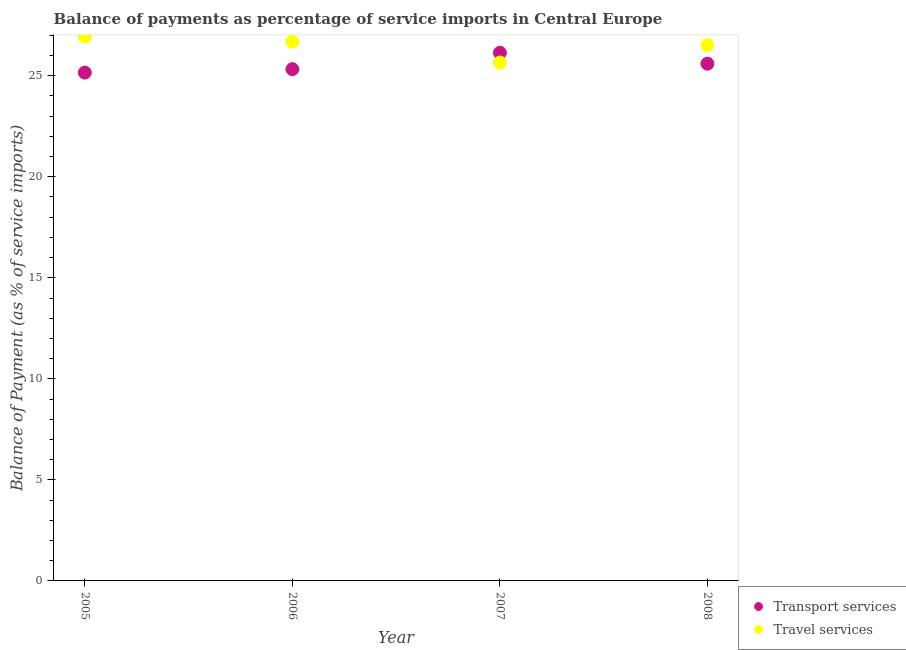What is the balance of payments of travel services in 2007?
Offer a very short reply. 25.65. Across all years, what is the maximum balance of payments of travel services?
Make the answer very short. 26.93. Across all years, what is the minimum balance of payments of travel services?
Ensure brevity in your answer.  25.65. What is the total balance of payments of transport services in the graph?
Keep it short and to the point. 102.22. What is the difference between the balance of payments of travel services in 2005 and that in 2007?
Ensure brevity in your answer.  1.28. What is the difference between the balance of payments of travel services in 2006 and the balance of payments of transport services in 2008?
Your answer should be compact. 1.09. What is the average balance of payments of travel services per year?
Offer a terse response. 26.45. In the year 2006, what is the difference between the balance of payments of travel services and balance of payments of transport services?
Ensure brevity in your answer.  1.36. What is the ratio of the balance of payments of travel services in 2005 to that in 2007?
Offer a terse response. 1.05. Is the balance of payments of transport services in 2005 less than that in 2007?
Provide a succinct answer. Yes. Is the difference between the balance of payments of travel services in 2006 and 2008 greater than the difference between the balance of payments of transport services in 2006 and 2008?
Your answer should be compact. Yes. What is the difference between the highest and the second highest balance of payments of travel services?
Offer a terse response. 0.25. What is the difference between the highest and the lowest balance of payments of transport services?
Make the answer very short. 0.98. In how many years, is the balance of payments of travel services greater than the average balance of payments of travel services taken over all years?
Offer a very short reply. 3. Does the balance of payments of transport services monotonically increase over the years?
Offer a very short reply. No. Is the balance of payments of travel services strictly greater than the balance of payments of transport services over the years?
Your answer should be very brief. No. Is the balance of payments of transport services strictly less than the balance of payments of travel services over the years?
Your answer should be very brief. No. How many dotlines are there?
Keep it short and to the point. 2. What is the difference between two consecutive major ticks on the Y-axis?
Offer a very short reply. 5. Does the graph contain any zero values?
Your answer should be compact. No. Does the graph contain grids?
Make the answer very short. No. How many legend labels are there?
Provide a succinct answer. 2. What is the title of the graph?
Give a very brief answer. Balance of payments as percentage of service imports in Central Europe. Does "International Visitors" appear as one of the legend labels in the graph?
Offer a very short reply. No. What is the label or title of the Y-axis?
Your answer should be very brief. Balance of Payment (as % of service imports). What is the Balance of Payment (as % of service imports) of Transport services in 2005?
Ensure brevity in your answer.  25.16. What is the Balance of Payment (as % of service imports) in Travel services in 2005?
Make the answer very short. 26.93. What is the Balance of Payment (as % of service imports) of Transport services in 2006?
Provide a short and direct response. 25.33. What is the Balance of Payment (as % of service imports) of Travel services in 2006?
Keep it short and to the point. 26.69. What is the Balance of Payment (as % of service imports) in Transport services in 2007?
Offer a very short reply. 26.14. What is the Balance of Payment (as % of service imports) of Travel services in 2007?
Keep it short and to the point. 25.65. What is the Balance of Payment (as % of service imports) of Transport services in 2008?
Offer a terse response. 25.6. What is the Balance of Payment (as % of service imports) in Travel services in 2008?
Keep it short and to the point. 26.52. Across all years, what is the maximum Balance of Payment (as % of service imports) of Transport services?
Your answer should be very brief. 26.14. Across all years, what is the maximum Balance of Payment (as % of service imports) in Travel services?
Offer a very short reply. 26.93. Across all years, what is the minimum Balance of Payment (as % of service imports) in Transport services?
Provide a short and direct response. 25.16. Across all years, what is the minimum Balance of Payment (as % of service imports) of Travel services?
Provide a succinct answer. 25.65. What is the total Balance of Payment (as % of service imports) in Transport services in the graph?
Give a very brief answer. 102.22. What is the total Balance of Payment (as % of service imports) in Travel services in the graph?
Your answer should be very brief. 105.79. What is the difference between the Balance of Payment (as % of service imports) of Transport services in 2005 and that in 2006?
Keep it short and to the point. -0.17. What is the difference between the Balance of Payment (as % of service imports) in Travel services in 2005 and that in 2006?
Provide a short and direct response. 0.25. What is the difference between the Balance of Payment (as % of service imports) in Transport services in 2005 and that in 2007?
Your response must be concise. -0.98. What is the difference between the Balance of Payment (as % of service imports) of Travel services in 2005 and that in 2007?
Your answer should be very brief. 1.28. What is the difference between the Balance of Payment (as % of service imports) of Transport services in 2005 and that in 2008?
Offer a very short reply. -0.44. What is the difference between the Balance of Payment (as % of service imports) in Travel services in 2005 and that in 2008?
Your response must be concise. 0.42. What is the difference between the Balance of Payment (as % of service imports) in Transport services in 2006 and that in 2007?
Your response must be concise. -0.81. What is the difference between the Balance of Payment (as % of service imports) in Travel services in 2006 and that in 2007?
Keep it short and to the point. 1.03. What is the difference between the Balance of Payment (as % of service imports) in Transport services in 2006 and that in 2008?
Make the answer very short. -0.27. What is the difference between the Balance of Payment (as % of service imports) in Travel services in 2006 and that in 2008?
Ensure brevity in your answer.  0.17. What is the difference between the Balance of Payment (as % of service imports) in Transport services in 2007 and that in 2008?
Give a very brief answer. 0.54. What is the difference between the Balance of Payment (as % of service imports) of Travel services in 2007 and that in 2008?
Provide a succinct answer. -0.86. What is the difference between the Balance of Payment (as % of service imports) in Transport services in 2005 and the Balance of Payment (as % of service imports) in Travel services in 2006?
Keep it short and to the point. -1.53. What is the difference between the Balance of Payment (as % of service imports) in Transport services in 2005 and the Balance of Payment (as % of service imports) in Travel services in 2007?
Ensure brevity in your answer.  -0.5. What is the difference between the Balance of Payment (as % of service imports) of Transport services in 2005 and the Balance of Payment (as % of service imports) of Travel services in 2008?
Provide a short and direct response. -1.36. What is the difference between the Balance of Payment (as % of service imports) in Transport services in 2006 and the Balance of Payment (as % of service imports) in Travel services in 2007?
Keep it short and to the point. -0.33. What is the difference between the Balance of Payment (as % of service imports) of Transport services in 2006 and the Balance of Payment (as % of service imports) of Travel services in 2008?
Make the answer very short. -1.19. What is the difference between the Balance of Payment (as % of service imports) in Transport services in 2007 and the Balance of Payment (as % of service imports) in Travel services in 2008?
Offer a terse response. -0.38. What is the average Balance of Payment (as % of service imports) of Transport services per year?
Provide a short and direct response. 25.55. What is the average Balance of Payment (as % of service imports) of Travel services per year?
Ensure brevity in your answer.  26.45. In the year 2005, what is the difference between the Balance of Payment (as % of service imports) of Transport services and Balance of Payment (as % of service imports) of Travel services?
Keep it short and to the point. -1.78. In the year 2006, what is the difference between the Balance of Payment (as % of service imports) in Transport services and Balance of Payment (as % of service imports) in Travel services?
Keep it short and to the point. -1.36. In the year 2007, what is the difference between the Balance of Payment (as % of service imports) in Transport services and Balance of Payment (as % of service imports) in Travel services?
Provide a succinct answer. 0.49. In the year 2008, what is the difference between the Balance of Payment (as % of service imports) in Transport services and Balance of Payment (as % of service imports) in Travel services?
Offer a terse response. -0.92. What is the ratio of the Balance of Payment (as % of service imports) of Travel services in 2005 to that in 2006?
Your answer should be compact. 1.01. What is the ratio of the Balance of Payment (as % of service imports) of Transport services in 2005 to that in 2007?
Ensure brevity in your answer.  0.96. What is the ratio of the Balance of Payment (as % of service imports) in Travel services in 2005 to that in 2007?
Ensure brevity in your answer.  1.05. What is the ratio of the Balance of Payment (as % of service imports) of Transport services in 2005 to that in 2008?
Keep it short and to the point. 0.98. What is the ratio of the Balance of Payment (as % of service imports) in Travel services in 2005 to that in 2008?
Your answer should be very brief. 1.02. What is the ratio of the Balance of Payment (as % of service imports) of Transport services in 2006 to that in 2007?
Offer a very short reply. 0.97. What is the ratio of the Balance of Payment (as % of service imports) of Travel services in 2006 to that in 2007?
Ensure brevity in your answer.  1.04. What is the ratio of the Balance of Payment (as % of service imports) of Transport services in 2006 to that in 2008?
Your answer should be compact. 0.99. What is the ratio of the Balance of Payment (as % of service imports) of Travel services in 2006 to that in 2008?
Provide a short and direct response. 1.01. What is the ratio of the Balance of Payment (as % of service imports) in Transport services in 2007 to that in 2008?
Provide a succinct answer. 1.02. What is the ratio of the Balance of Payment (as % of service imports) of Travel services in 2007 to that in 2008?
Make the answer very short. 0.97. What is the difference between the highest and the second highest Balance of Payment (as % of service imports) of Transport services?
Provide a succinct answer. 0.54. What is the difference between the highest and the second highest Balance of Payment (as % of service imports) in Travel services?
Keep it short and to the point. 0.25. What is the difference between the highest and the lowest Balance of Payment (as % of service imports) in Transport services?
Provide a short and direct response. 0.98. What is the difference between the highest and the lowest Balance of Payment (as % of service imports) of Travel services?
Provide a succinct answer. 1.28. 